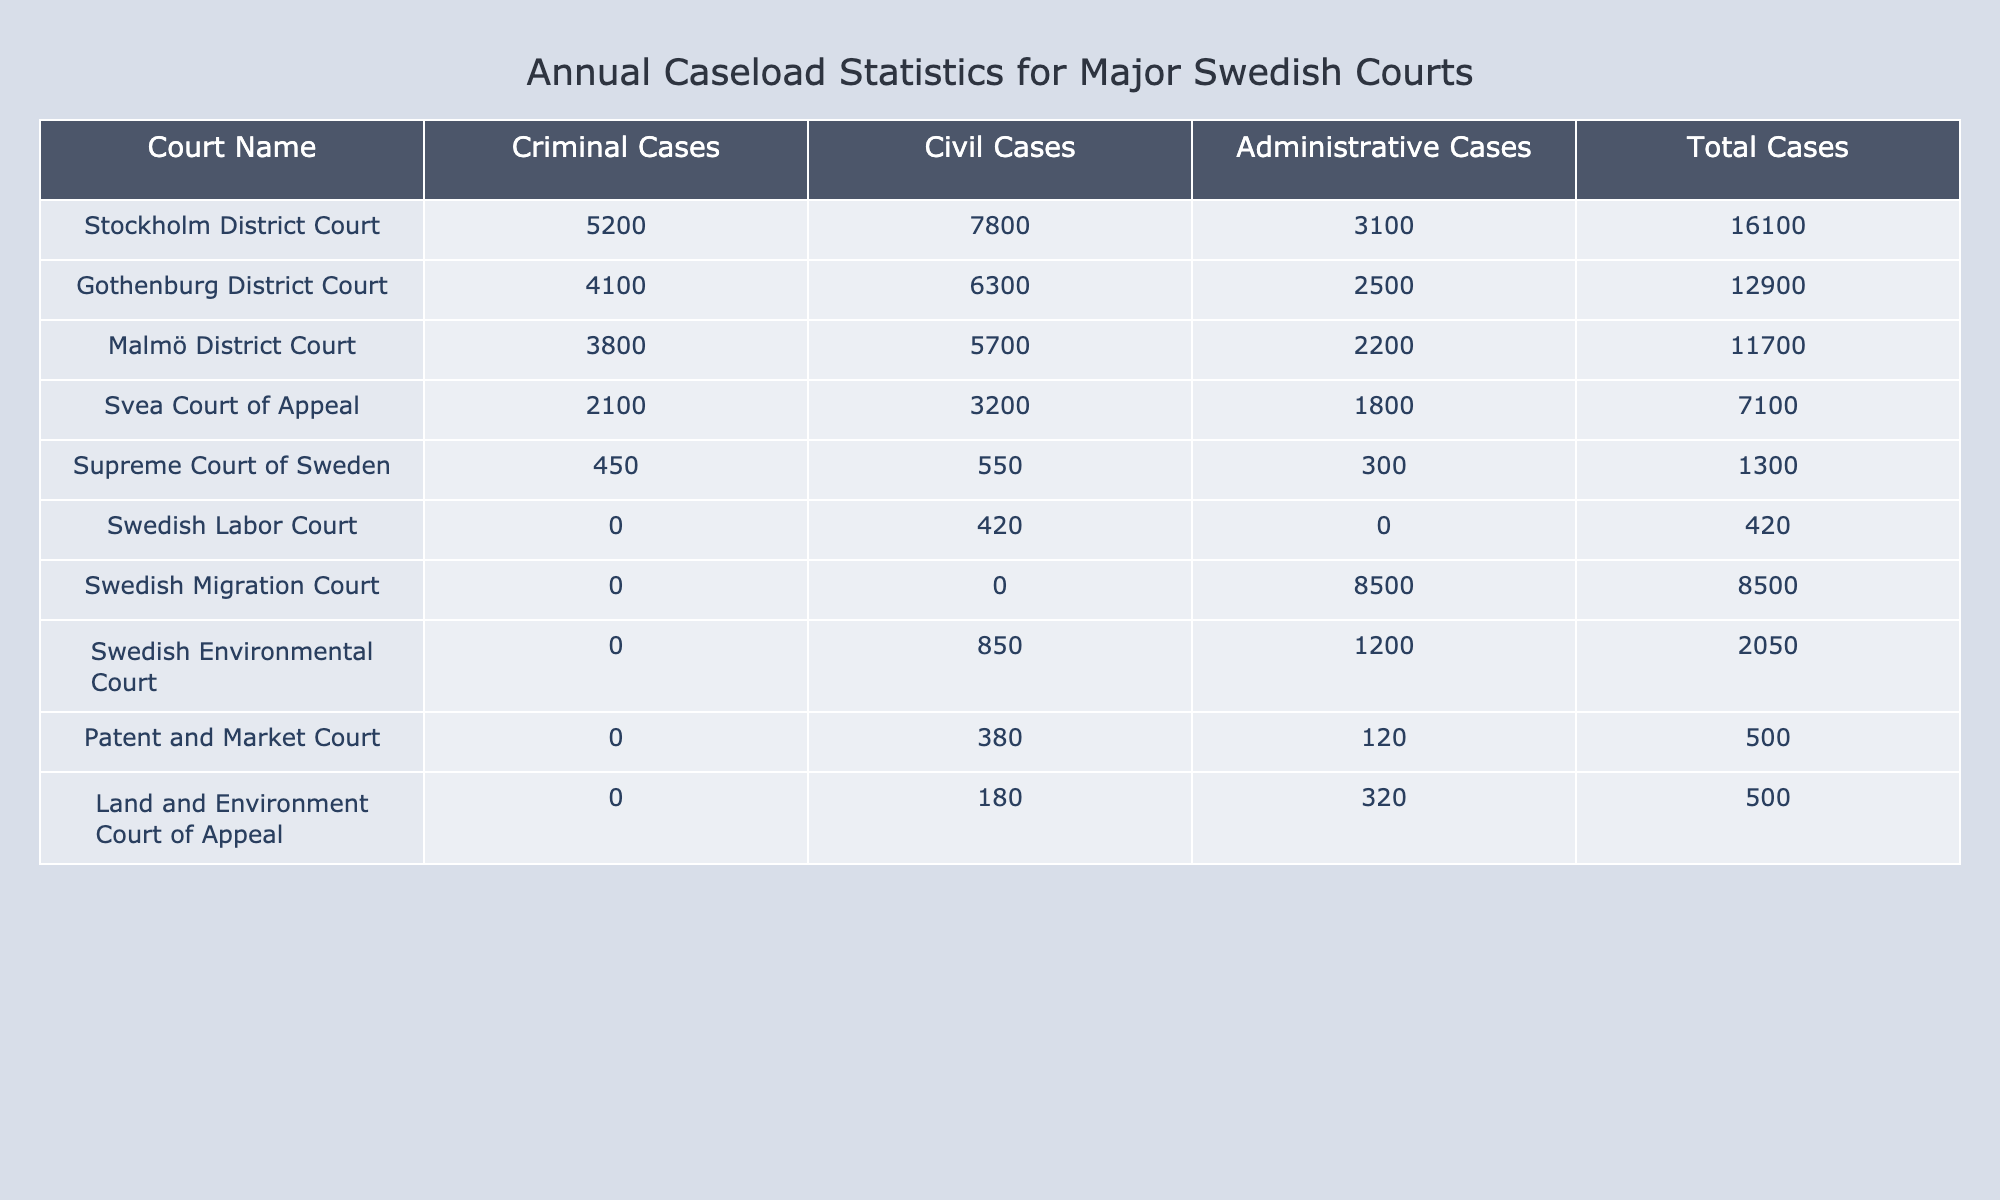What is the total number of criminal cases in the Stockholm District Court? The Stockholm District Court has reported 5200 criminal cases as per the data provided.
Answer: 5200 Which court has the highest total caseload? By examining the "Total Cases" column, the Stockholm District Court has the highest total of 16100 cases compared to other courts listed.
Answer: Stockholm District Court What are the total civil cases across all courts? To find the total civil cases, we add up the civil cases: 7800 (Stockholm) + 6300 (Gothenburg) + 5700 (Malmö) + 3200 (Svea) + 550 (Supreme) + 420 (Labor) + 0 (Migration) + 850 (Environmental) + 380 (Patent) + 180 (Land) = 18500.
Answer: 18500 Are there any courts with zero cases in the criminal category? By reviewing the table, the Swedish Labor Court and the Swedish Migration Court have zero criminal cases according to the data.
Answer: Yes What percentage of the total cases at the Malmö District Court are administrative cases? To find the percentage of administrative cases in Malmö District Court, we take the number of administrative cases (2200) and divide it by the total cases (11700), resulting in (2200/11700) * 100 ≈ 18.8%.
Answer: 18.8% Which court hears only administrative cases? The Swedish Migration Court exclusively handles administrative cases, with a total of 8500 cases in that category.
Answer: Swedish Migration Court What is the average number of total cases for the three district courts in Sweden? The total cases for the three district courts (Stockholm, Gothenburg, Malmö) are 16100, 12900, and 11700 respectively. Summing these up gives 40700 total cases. Dividing this by 3 (the number of courts) gives an average of 13566.67.
Answer: 13566.67 How many more civil cases are there in the Stockholm District Court than in the Gothenburg District Court? The difference in civil cases is calculated by subtracting the civil cases in Gothenburg (6300) from those in Stockholm (7800): 7800 - 6300 = 1500.
Answer: 1500 What is the total number of cases in the Svea Court of Appeal? The total number of cases in the Svea Court of Appeal is 7100, which is listed in the "Total Cases" column.
Answer: 7100 